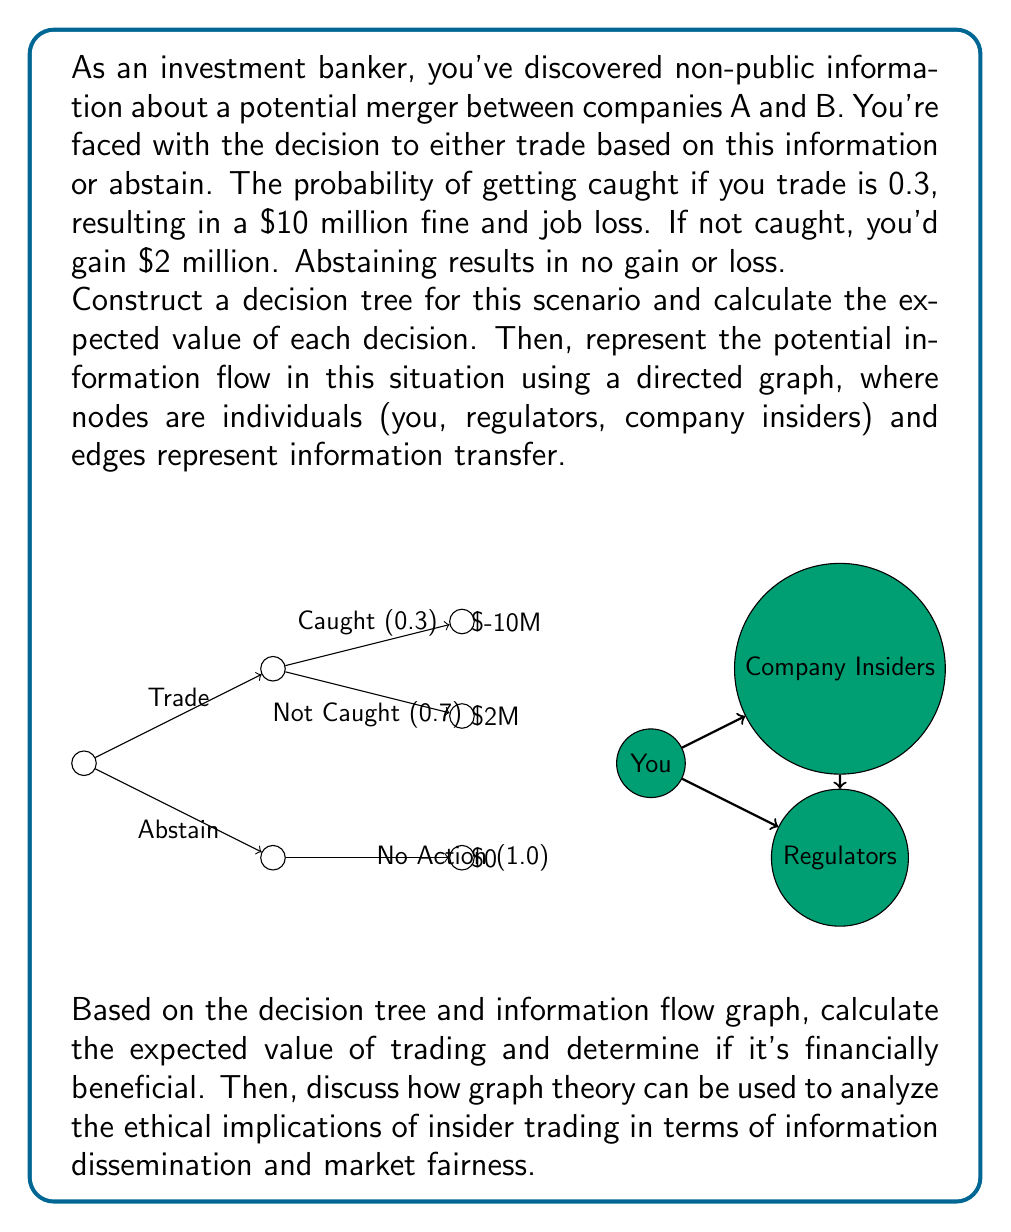Can you solve this math problem? Let's approach this problem step by step:

1) First, we'll calculate the expected value of trading:

   Let $E(T)$ be the expected value of trading.
   $$E(T) = 0.3 \times (-10,000,000) + 0.7 \times 2,000,000$$
   $$E(T) = -3,000,000 + 1,400,000 = -1,600,000$$

2) The expected value of abstaining is simply 0.

3) From a purely financial perspective, abstaining ($0) is better than trading ($-1,600,000).

4) Now, let's analyze the ethical implications using graph theory:

   a) In the information flow graph, we have three nodes: You, Company Insiders, and Regulators.
   
   b) The edges represent the flow of information. In an ideal, ethical market, information should flow equally to all participants. However, insider trading creates an imbalance.
   
   c) We can use the concept of in-degree and out-degree to analyze this:
      - Company Insiders have an out-degree of 1 (to You) and in-degree of 0
      - You have an out-degree of 1 (to Regulators) and in-degree of 1
      - Regulators have an out-degree of 0 and in-degree of 2
   
   d) This imbalance in degrees indicates an unfair information advantage.

5) We can also use the concept of reachability in the graph:
   - There's no direct path from Company Insiders to Regulators, indicating a lack of transparency.
   - You act as a 'bridge' in this graph, controlling information flow.

6) The decision tree shows the risk-reward scenario, which can be seen as a representation of the ethical dilemma. The negative expected value of trading despite the potential for high gains illustrates the regulatory attempt to discourage insider trading.

7) From an ethical standpoint, the goal would be to create a complete graph where all nodes are directly connected, ensuring fair and equal information distribution.
Answer: $E(Trade) = -1,600,000$; $E(Abstain) = 0$. Abstaining is financially better. Ethically, the graph shows information imbalance and lack of transparency, violating market fairness principles. 